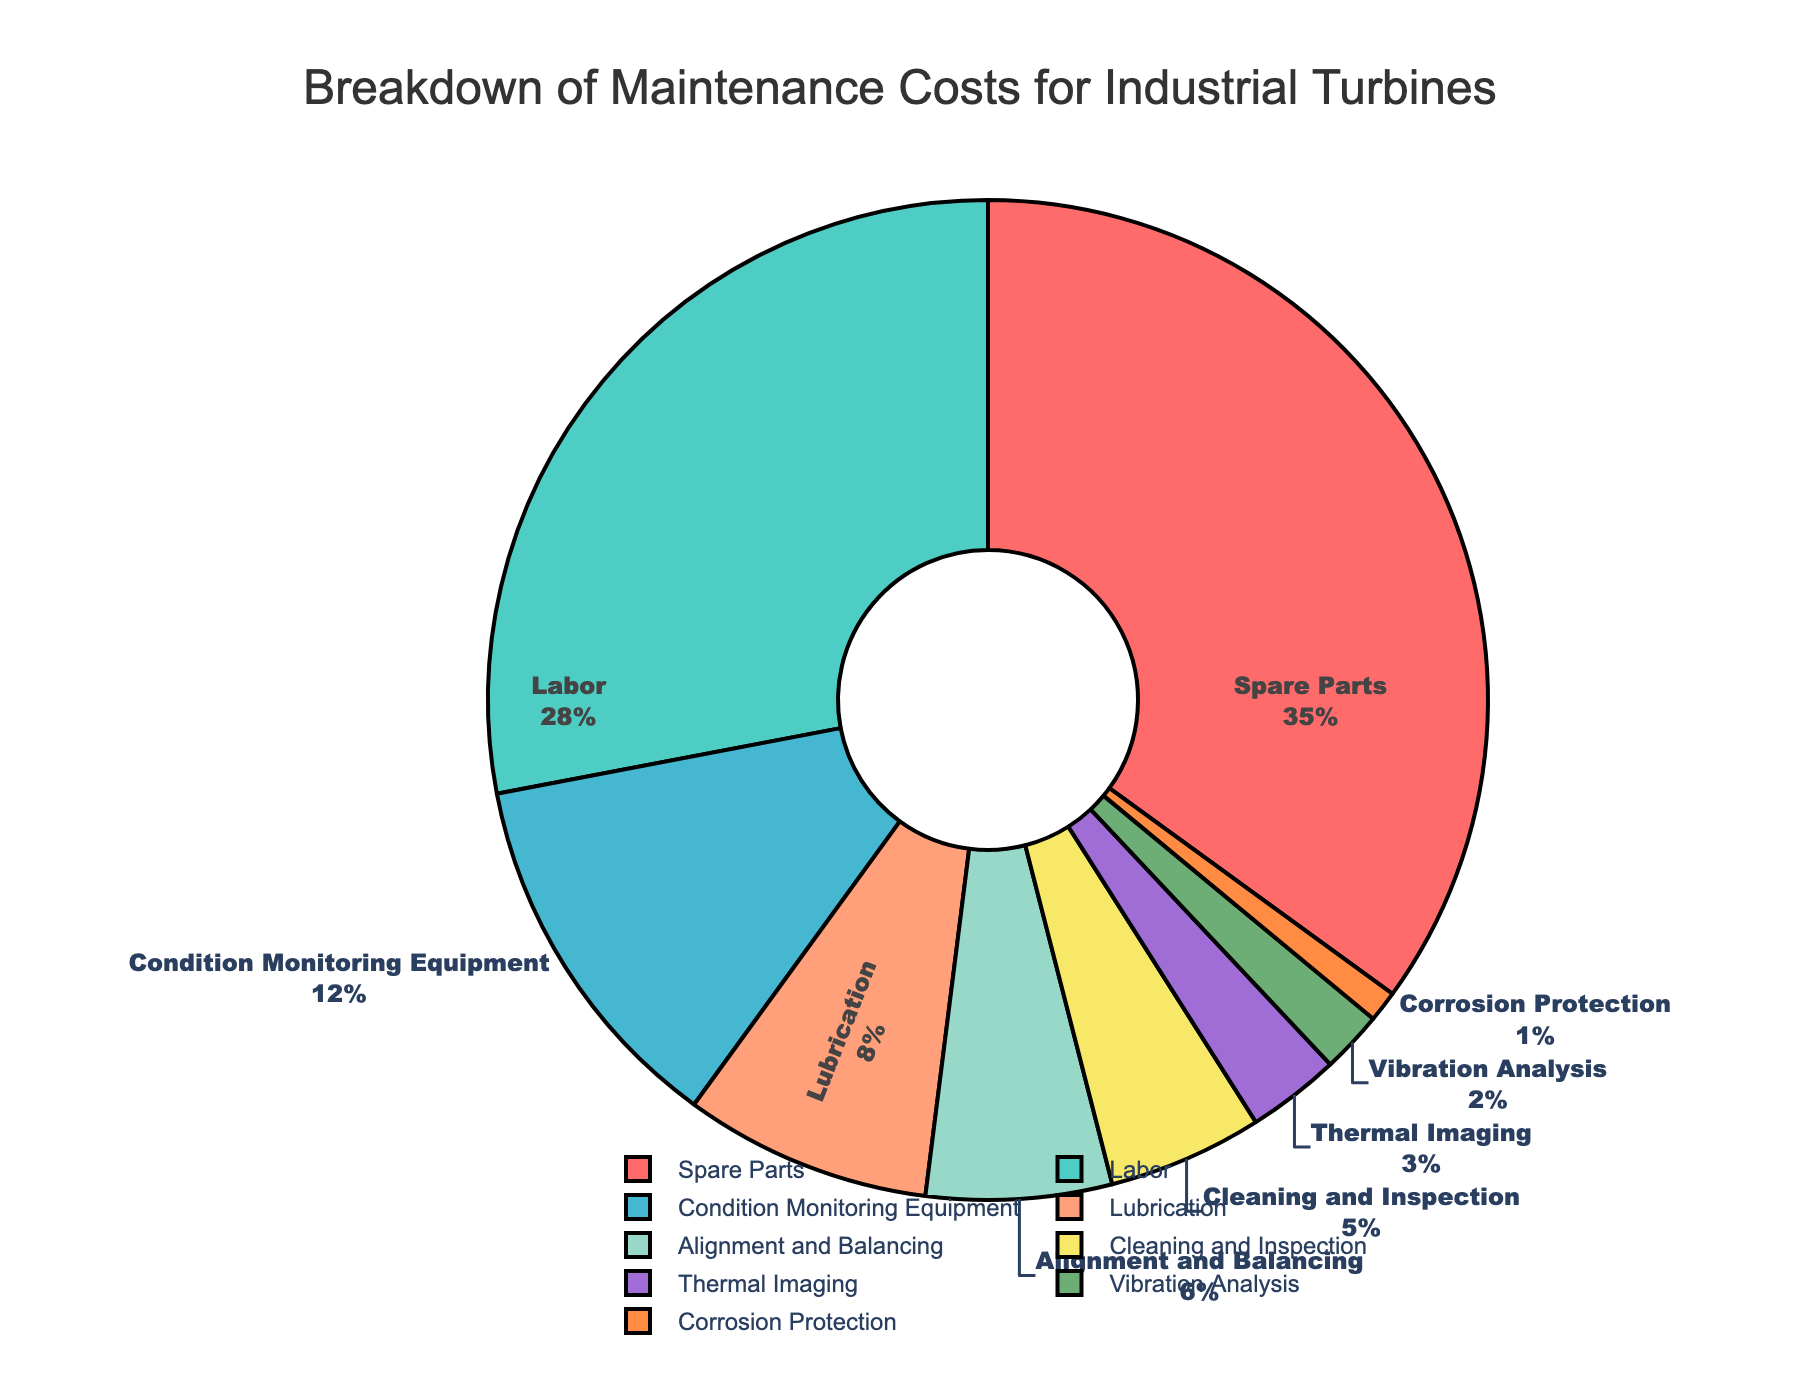What is the category with the highest maintenance cost percentage? The pie chart shows different categories and their respective percentages. The largest slice is identified by looking at the biggest section in the pie chart. The "Spare Parts" section is the largest at 35%.
Answer: Spare Parts Which two categories together make up more than 60% of the maintenance costs? By visually examining the pie chart, "Spare Parts" has 35% and "Labor" has 28%. Adding these two percentages together gives 35% + 28%, which equals 63%.
Answer: Spare Parts and Labor What is the difference in percentage between Labor and Lubrication costs? The pie chart shows that Labor accounts for 28% and Lubrication for 8%. Subtracting the smaller percentage from the larger one gives 28% - 8%, which equals 20%.
Answer: 20% How does the percentage for Cleaning and Inspection compare with that for Condition Monitoring Equipment? By comparing the two sections of the pie chart visually, Cleaning and Inspection is 5%, while Condition Monitoring Equipment is 12%. Since 12% is greater than 5%, Condition Monitoring Equipment has a higher percentage.
Answer: Condition Monitoring Equipment is higher What is the combined percentage for Alignment and Balancing, Thermal Imaging, and Vibration Analysis? Looking at the pie chart, Alignment and Balancing is 6%, Thermal Imaging is 3%, and Vibration Analysis is 2%. Adding these three percentages together gives 6% + 3% + 2%, which equals 11%.
Answer: 11% Which category has the smallest percentage, and what is that percentage? Identify the smallest slice in the pie chart, which is labeled "Corrosion Protection" with a percentage of 1%.
Answer: Corrosion Protection, 1% Compare the combined percentage of Condition Monitoring Equipment and Lubrication with the percentage of Spare Parts. Which is greater? The chart shows Condition Monitoring Equipment at 12% and Lubrication at 8%. Combining these gives 12% + 8%, which equals 20%. Spare Parts is 35%. Since 35% is greater than 20%, Spare Parts has a higher percentage.
Answer: Spare Parts is greater Given only the visual information, what can you infer about the relative importance of Spare Parts compared to Corrosion Protection in maintenance costs? The pie chart shows that Spare Parts is 35%, while Corrosion Protection is 1%. This significant difference suggests that Spare Parts are far more important in terms of maintenance costs.
Answer: Spare Parts is far more important What color is used to represent the Labor category, and what is its percentage? The pie chart visually shows that the slice representing Labor is colored turquoise, and from the chart, Labor has a percentage of 28%.
Answer: Turquoise, 28% 